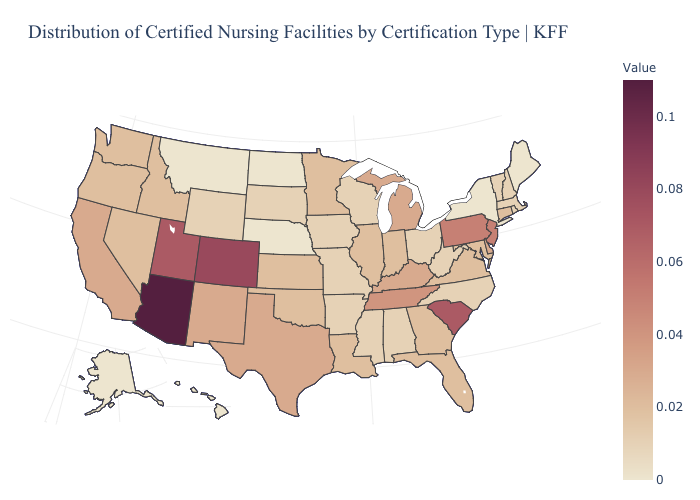Which states have the highest value in the USA?
Short answer required. Arizona. Which states hav the highest value in the West?
Answer briefly. Arizona. Among the states that border Vermont , which have the lowest value?
Write a very short answer. New York. Does North Carolina have the lowest value in the South?
Quick response, please. Yes. Which states have the lowest value in the West?
Quick response, please. Alaska, Hawaii, Montana. 